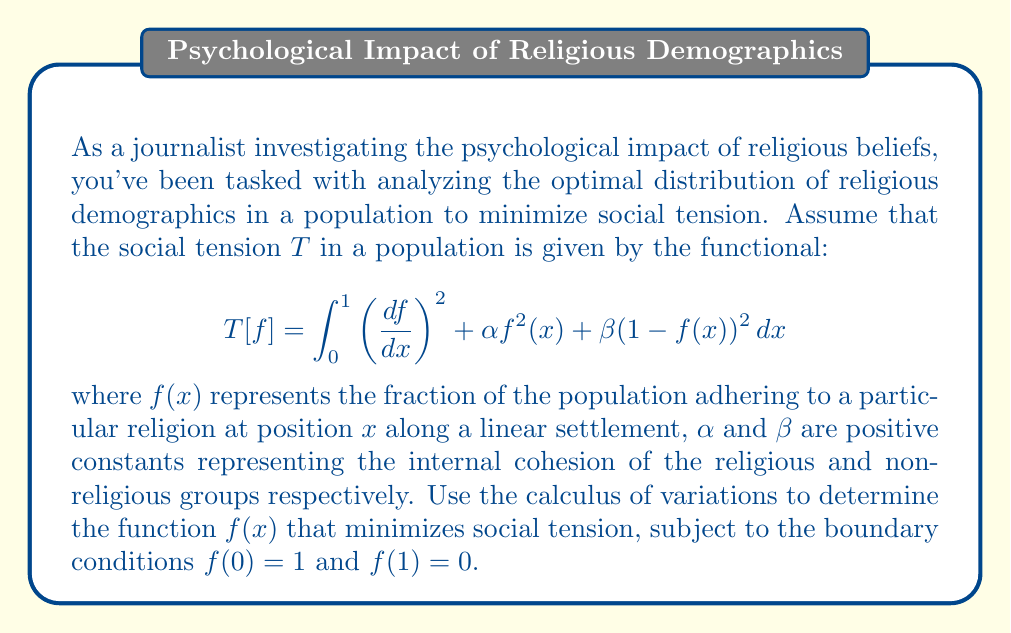Give your solution to this math problem. To solve this problem, we'll use the Euler-Lagrange equation from the calculus of variations. The steps are as follows:

1) The Euler-Lagrange equation is given by:

   $$\frac{\partial F}{\partial f} - \frac{d}{dx}\left(\frac{\partial F}{\partial f'}\right) = 0$$

   where $F$ is the integrand of our functional.

2) In our case, $F = (f')^2 + \alpha f^2 + \beta(1-f)^2$

3) We calculate the partial derivatives:

   $\frac{\partial F}{\partial f} = 2\alpha f - 2\beta(1-f) = 2(\alpha+\beta)f - 2\beta$

   $\frac{\partial F}{\partial f'} = 2f'$

4) Substituting into the Euler-Lagrange equation:

   $2(\alpha+\beta)f - 2\beta - \frac{d}{dx}(2f') = 0$

5) Simplifying:

   $(\alpha+\beta)f - \beta - f'' = 0$

6) Rearranging:

   $f'' - (\alpha+\beta)f = -\beta$

7) This is a second-order linear differential equation. The general solution has the form:

   $f(x) = A e^{\sqrt{\alpha+\beta}x} + B e^{-\sqrt{\alpha+\beta}x} + \frac{\beta}{\alpha+\beta}$

8) Using the boundary conditions:

   At $x=0$: $1 = A + B + \frac{\beta}{\alpha+\beta}$
   At $x=1$: $0 = A e^{\sqrt{\alpha+\beta}} + B e^{-\sqrt{\alpha+\beta}} + \frac{\beta}{\alpha+\beta}$

9) Solving this system of equations:

   $A = \frac{1}{2}\left(1 - \frac{\beta}{\alpha+\beta}\right)\frac{e^{\sqrt{\alpha+\beta}}}{e^{\sqrt{\alpha+\beta}} - e^{-\sqrt{\alpha+\beta}}}$

   $B = \frac{1}{2}\left(1 - \frac{\beta}{\alpha+\beta}\right)\frac{e^{-\sqrt{\alpha+\beta}}}{e^{-\sqrt{\alpha+\beta}} - e^{\sqrt{\alpha+\beta}}}$

10) The final solution is:

    $f(x) = \frac{1}{2}\left(1 - \frac{\beta}{\alpha+\beta}\right)\frac{e^{\sqrt{\alpha+\beta}(1-2x)} - 1}{e^{\sqrt{\alpha+\beta}} - e^{-\sqrt{\alpha+\beta}}} + \frac{\beta}{\alpha+\beta}$

This function $f(x)$ represents the optimal distribution of the religious demographic that minimizes social tension under the given conditions.
Answer: The optimal distribution of the religious demographic that minimizes social tension is given by:

$$f(x) = \frac{1}{2}\left(1 - \frac{\beta}{\alpha+\beta}\right)\frac{e^{\sqrt{\alpha+\beta}(1-2x)} - 1}{e^{\sqrt{\alpha+\beta}} - e^{-\sqrt{\alpha+\beta}}} + \frac{\beta}{\alpha+\beta}$$

where $\alpha$ and $\beta$ are the given positive constants, and $x$ is the position along the linear settlement. 